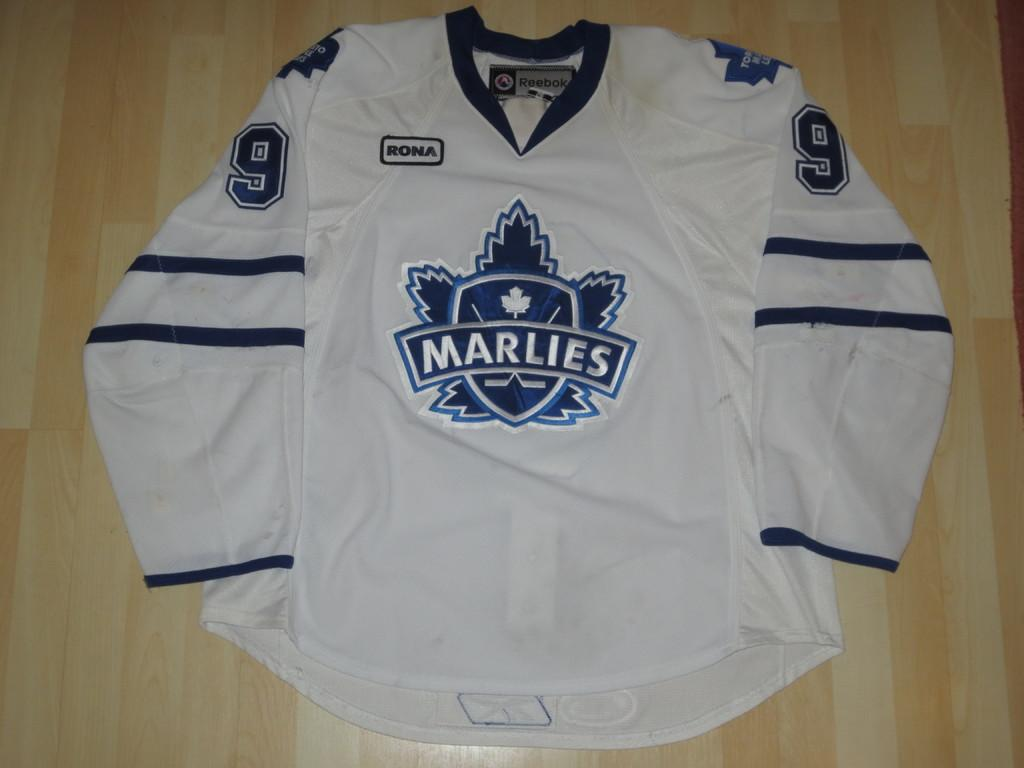<image>
Render a clear and concise summary of the photo. a white number 9 jersey that says 'marlies' on it 